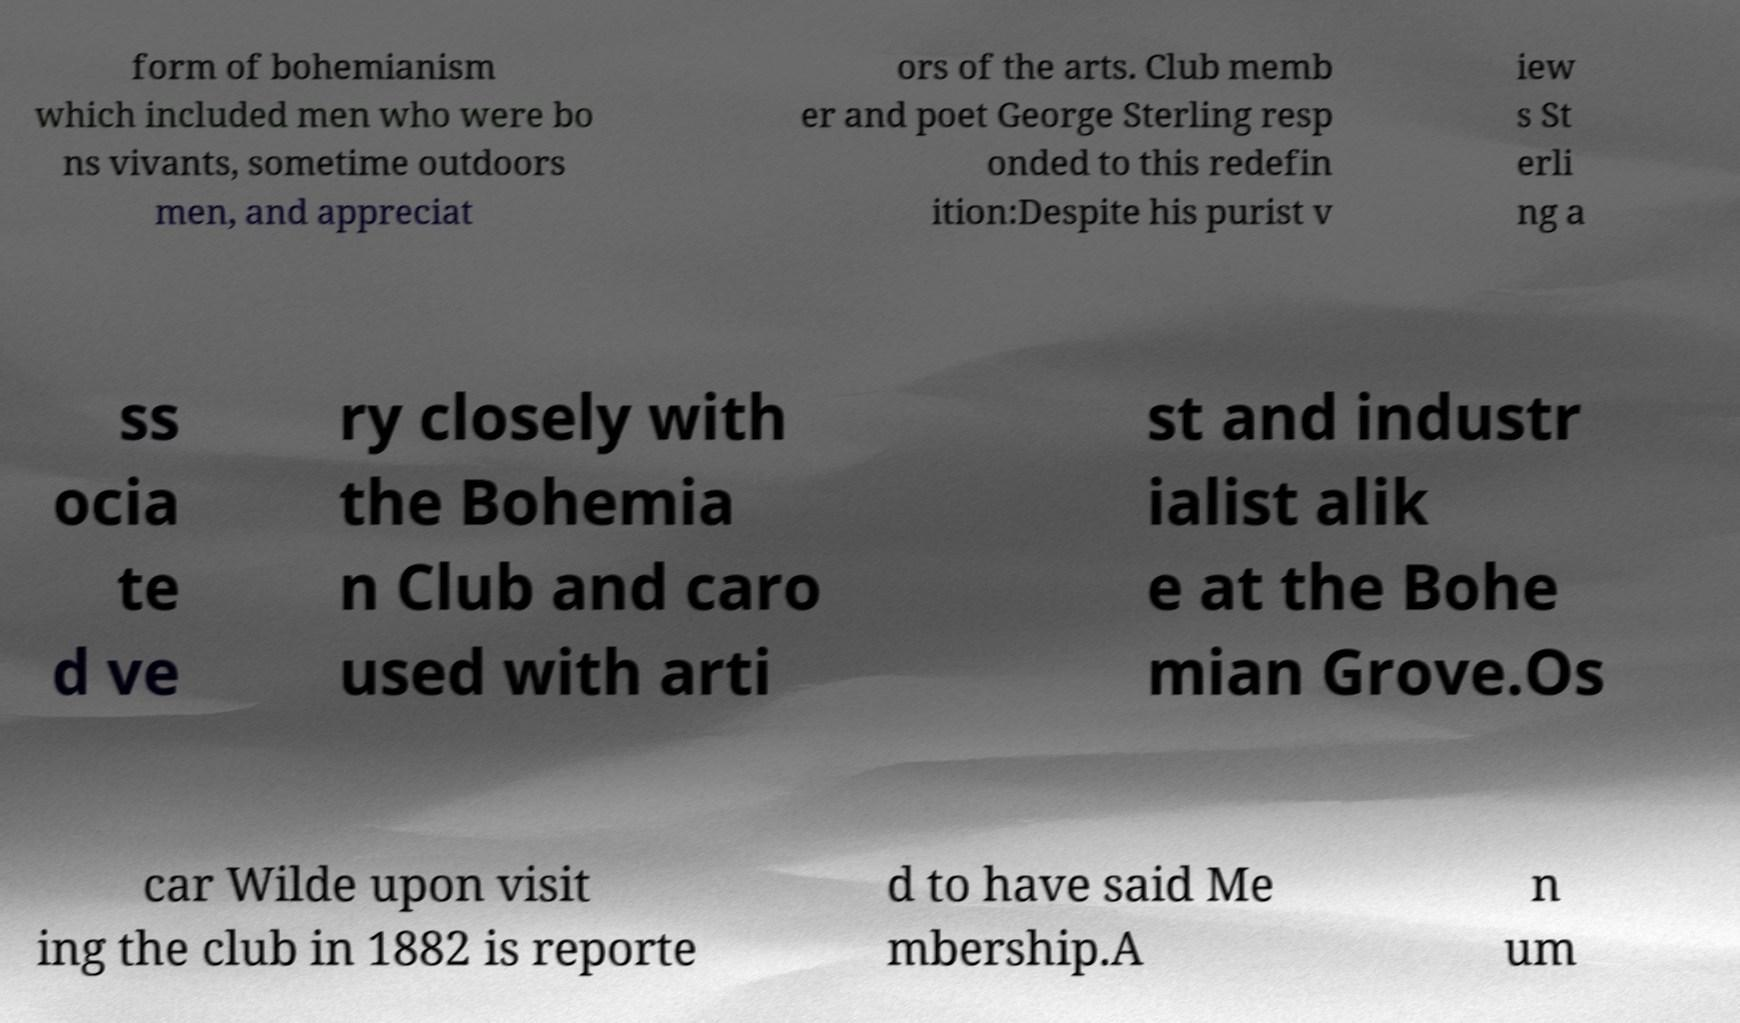Please read and relay the text visible in this image. What does it say? form of bohemianism which included men who were bo ns vivants, sometime outdoors men, and appreciat ors of the arts. Club memb er and poet George Sterling resp onded to this redefin ition:Despite his purist v iew s St erli ng a ss ocia te d ve ry closely with the Bohemia n Club and caro used with arti st and industr ialist alik e at the Bohe mian Grove.Os car Wilde upon visit ing the club in 1882 is reporte d to have said Me mbership.A n um 